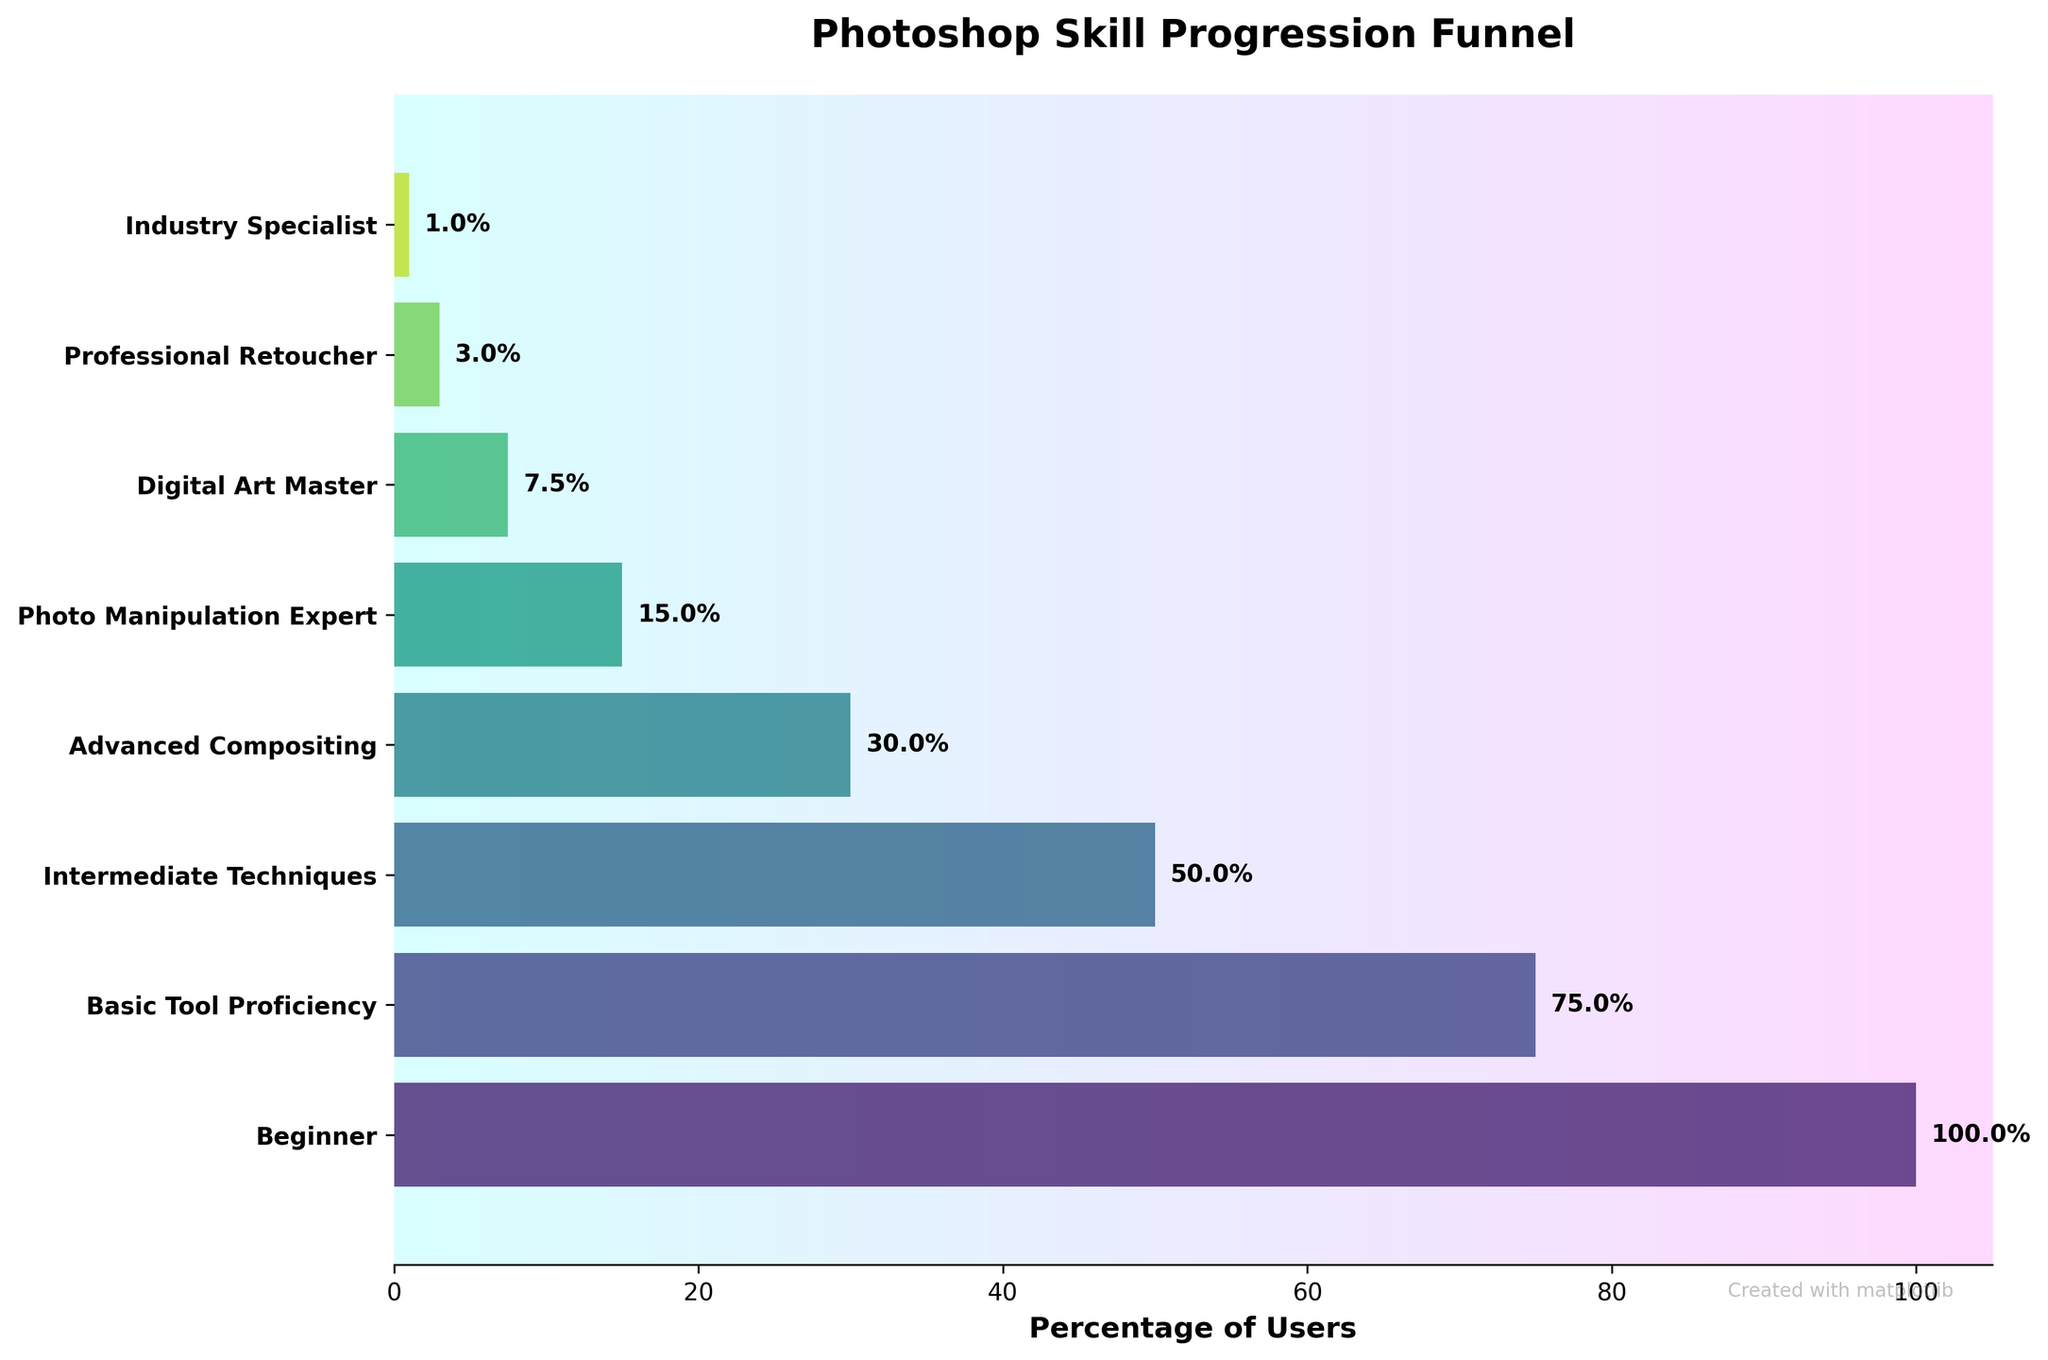what is the title of the chart? The title of the chart is typically displayed at the top. The title in this figure is "Photoshop Skill Progression Funnel."
Answer: Photoshop Skill Progression Funnel How many stages are shown in the funnel? Count the distinct stages listed on the vertical axis of the funnel chart to find the total number of stages. The stages listed are Beginner, Basic Tool Proficiency, Intermediate Techniques, Advanced Compositing, Photo Manipulation Expert, Digital Art Master, Professional Retoucher, and Industry Specialist, which total 8 stages.
Answer: 8 Which stage has the lowest percentage of users? Identify the smallest percentage value at the end of each horizontal bar. The lowest percentage in this funnel chart is for the Industry Specialist stage, which shows 1%.
Answer: Industry Specialist What is the difference in user percentage between Basic Tool Proficiency and Advanced Compositing stages? Subtract the percentage of the Advanced Compositing stage from the percentage of the Basic Tool Proficiency stage. Basic Tool Proficiency has 75% users, and Advanced Compositing has 30% users, so 75% - 30% = 45%.
Answer: 45% How many users are at the Intermediate Techniques stage? Locate the corresponding stage on the chart and refer to the percentage or number given. The Intermediate Techniques stage lists 50%, which corresponds to 50,000 users.
Answer: 50,000 Comparing Advanced Compositing and Professional Retoucher, which stage has a higher user percentage and by how much? Compare the percentages for both stages. Advanced Compositing has 30%, while Professional Retoucher has 3%. The difference is 30% - 3% = 27%.
Answer: Advanced Compositing by 27% Which stages have user percentages less than 10%? Identify and list the stages that have percentages below 10% by looking at the percentage labels. The stages with percentages less than 10% are Digital Art Master (7.5%), Professional Retoucher (3%), and Industry Specialist (1%).
Answer: Digital Art Master, Professional Retoucher, Industry Specialist What percentage of users are in the top three skill levels combined? Sum the percentages of the top three skill levels in the funnel chart. The stages are Professional Retoucher (3%), Digital Art Master (7.5%), and Industry Specialist (1%). Therefore, the combined percentage is 3% + 7.5% + 1% = 11.5%.
Answer: 11.5% What stage do the majority of users belong to? Identify the stage with the highest percentage value. According to the funnel chart, the Beginner stage has the highest percentage at 100%.
Answer: Beginner What is the average percentage for Intermediate Techniques, Advanced Compositing, and Photo Manipulation Expert stages? Calculate the mean percentage of the three stages. Intermediate Techniques has 50%, Advanced Compositing has 30%, and Photo Manipulation Expert has 15%. The average is (50% + 30% + 15%)/3 = 95%/3 ≈ 31.67%.
Answer: 31.67% 